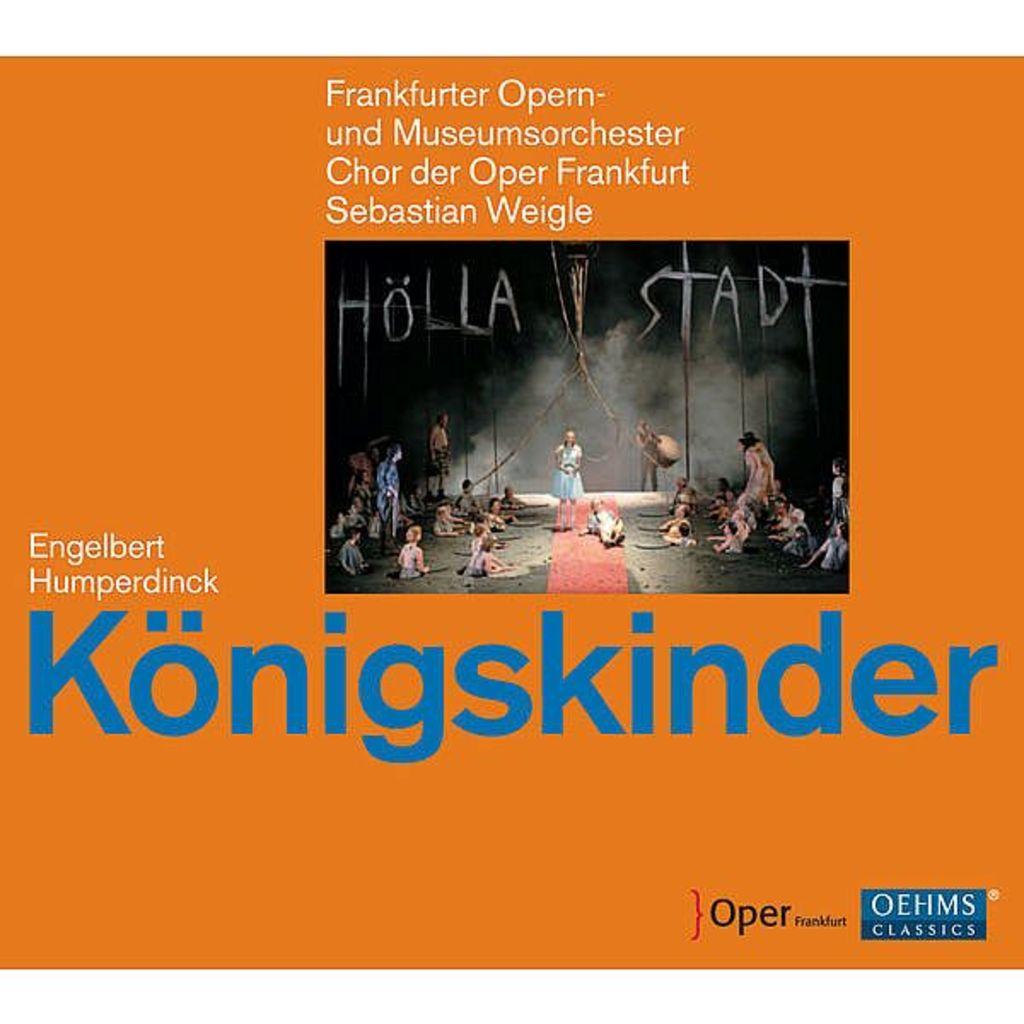What is the name of the actor?
Your answer should be compact. Engelbert humperdinck. What is the title of this?
Keep it short and to the point. Konigskinder. 